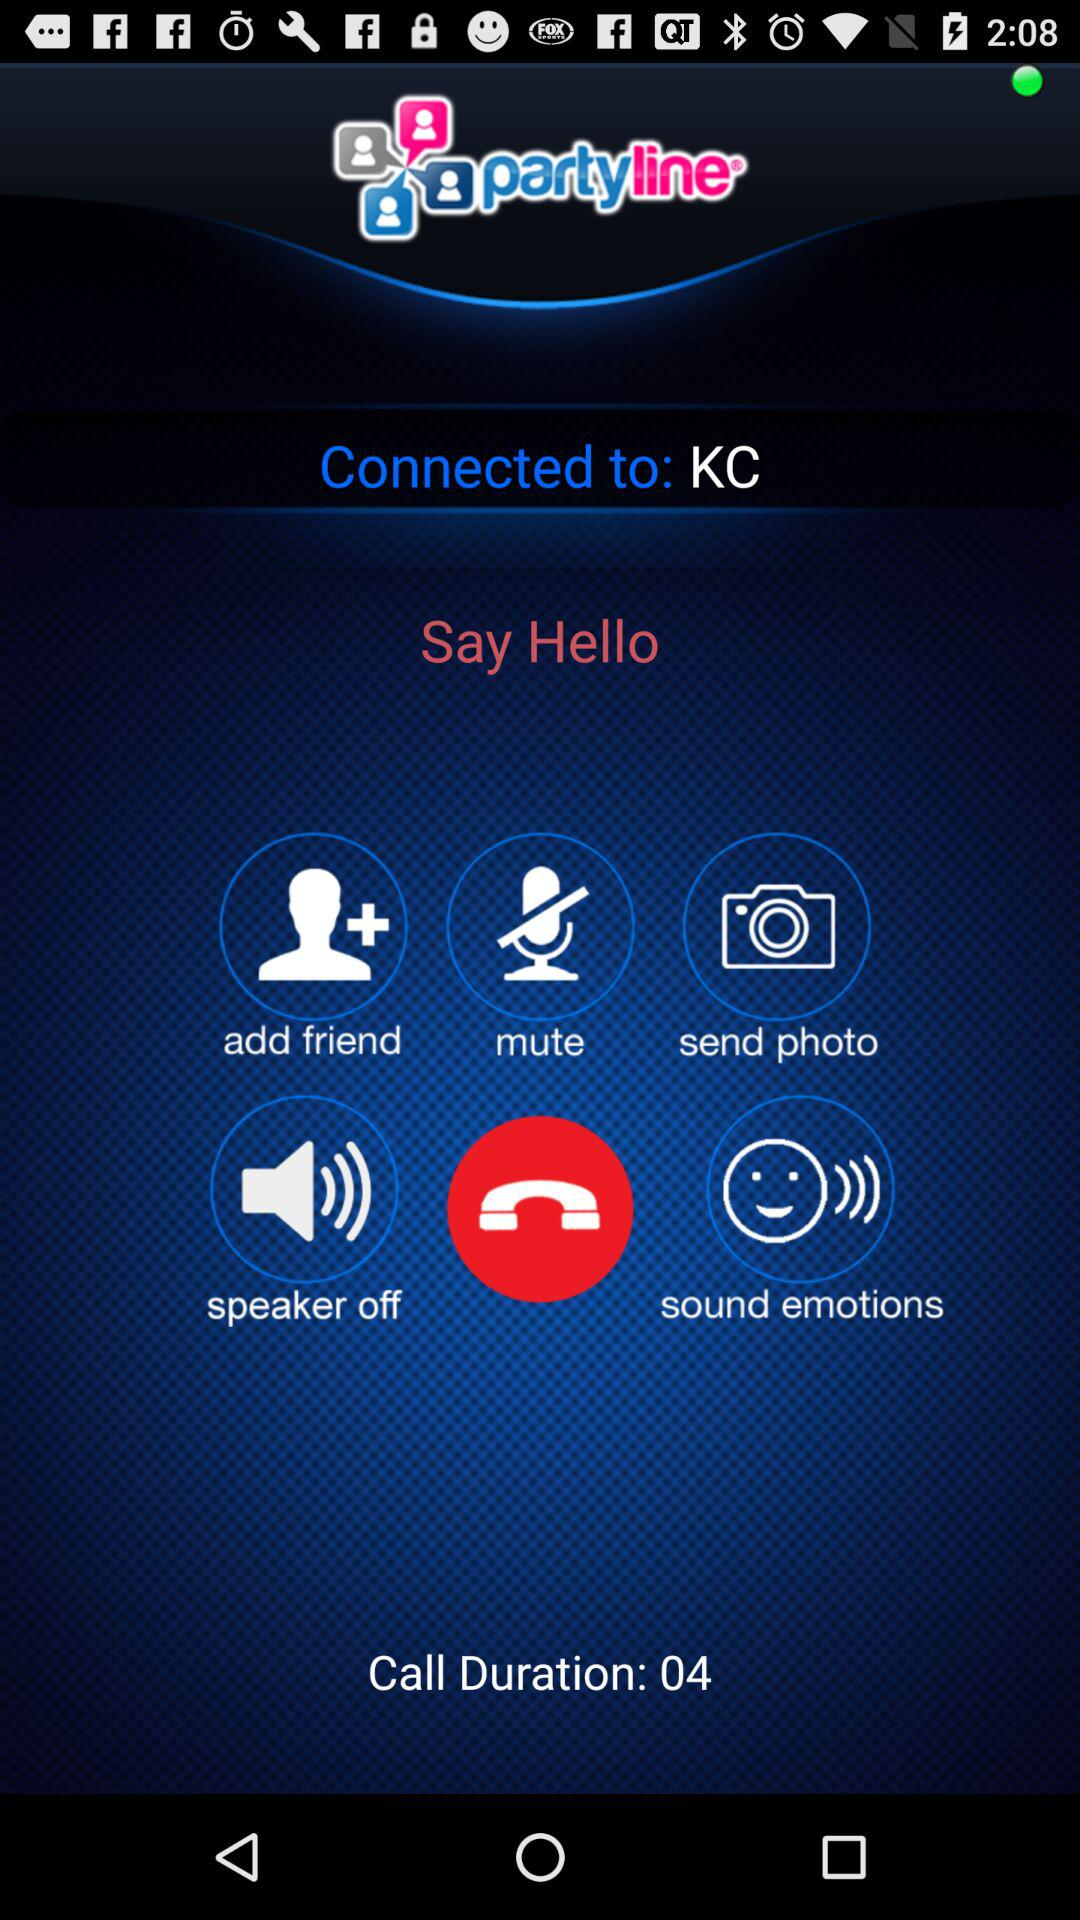How many seconds long is the call?
Answer the question using a single word or phrase. 4 